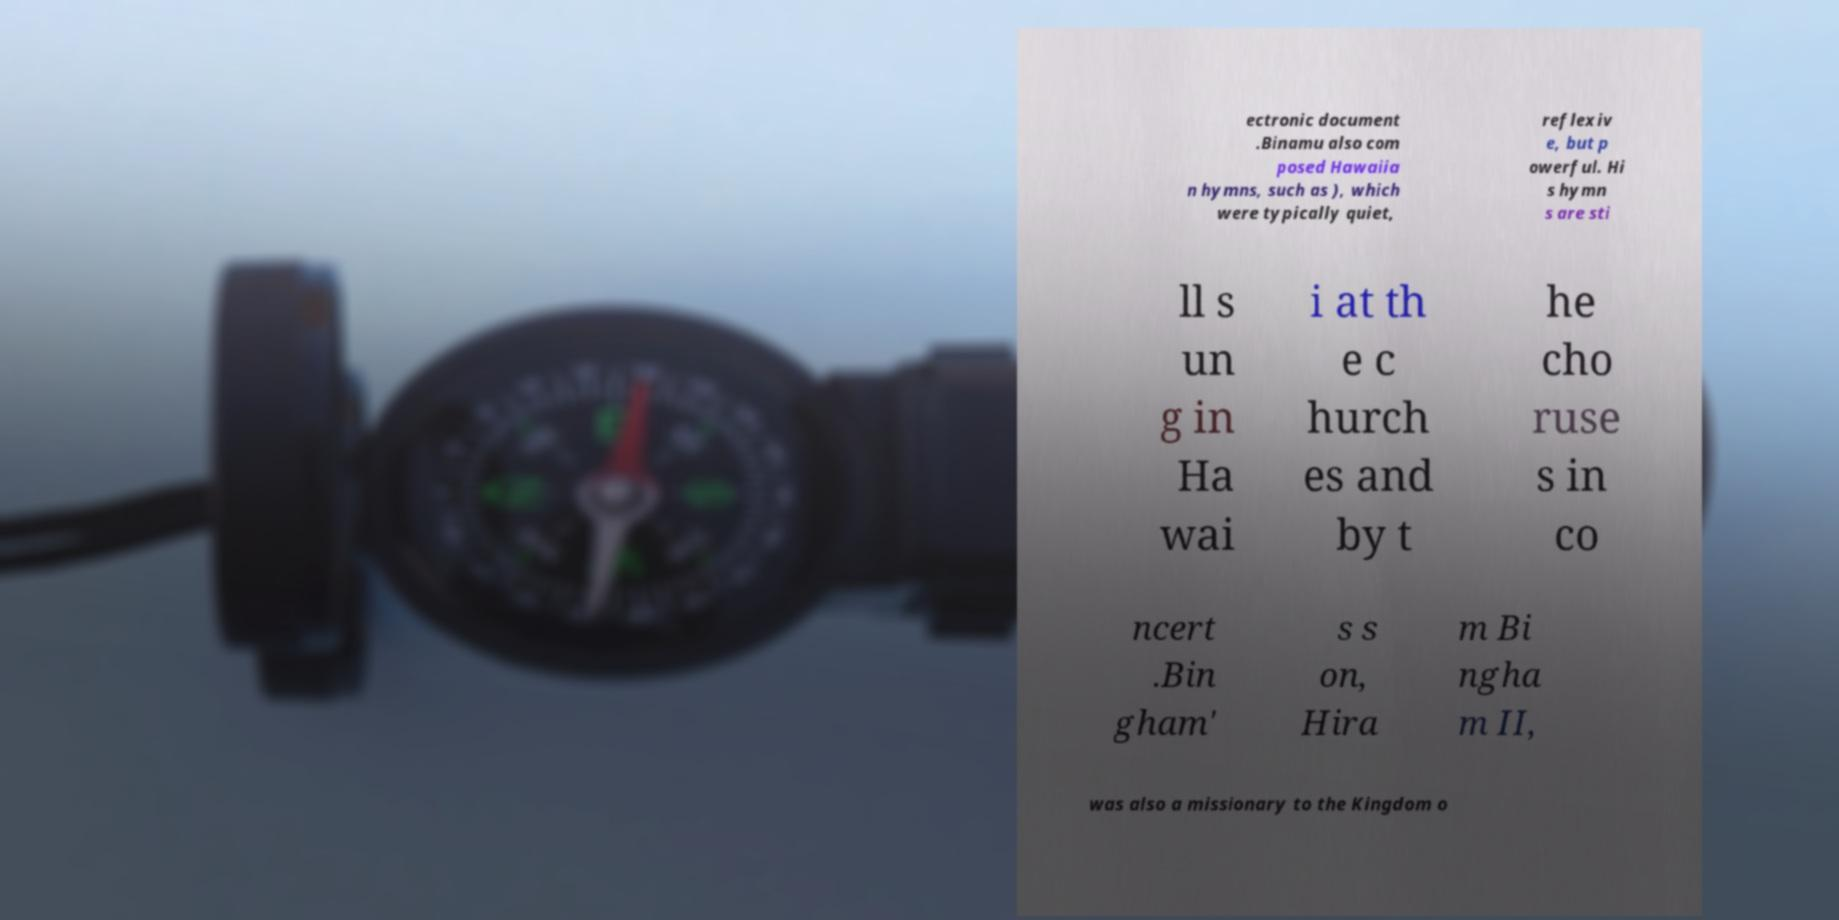Can you accurately transcribe the text from the provided image for me? ectronic document .Binamu also com posed Hawaiia n hymns, such as ), which were typically quiet, reflexiv e, but p owerful. Hi s hymn s are sti ll s un g in Ha wai i at th e c hurch es and by t he cho ruse s in co ncert .Bin gham' s s on, Hira m Bi ngha m II, was also a missionary to the Kingdom o 